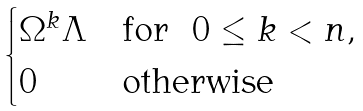Convert formula to latex. <formula><loc_0><loc_0><loc_500><loc_500>\begin{cases} \Omega ^ { k } \Lambda & \text {for \ } 0 \leq k < n , \\ 0 & \text {otherwise} \end{cases}</formula> 